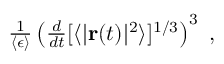Convert formula to latex. <formula><loc_0><loc_0><loc_500><loc_500>\begin{array} { r } { \frac { 1 } { \langle \epsilon \rangle } \left ( \frac { d } { d t } [ \langle | { r } ( t ) | ^ { 2 } \rangle ] ^ { 1 / 3 } \right ) ^ { 3 } \ , } \end{array}</formula> 